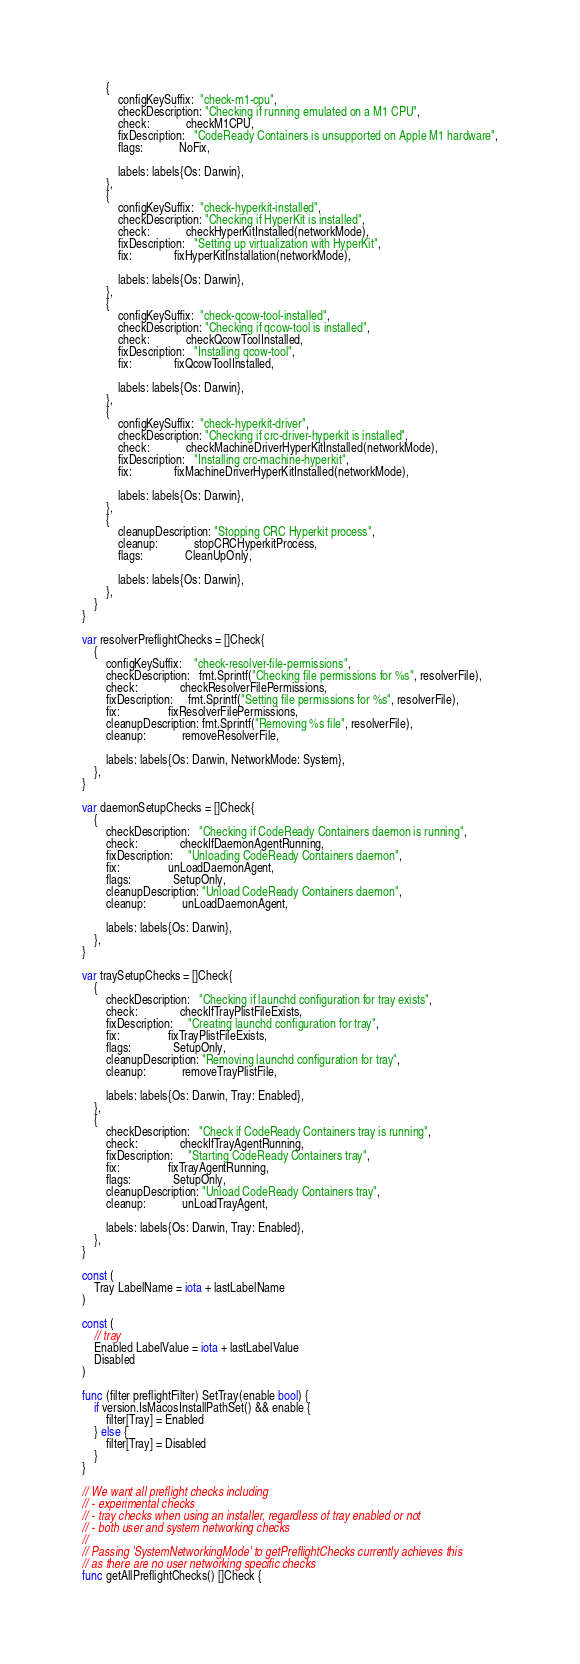<code> <loc_0><loc_0><loc_500><loc_500><_Go_>		{
			configKeySuffix:  "check-m1-cpu",
			checkDescription: "Checking if running emulated on a M1 CPU",
			check:            checkM1CPU,
			fixDescription:   "CodeReady Containers is unsupported on Apple M1 hardware",
			flags:            NoFix,

			labels: labels{Os: Darwin},
		},
		{
			configKeySuffix:  "check-hyperkit-installed",
			checkDescription: "Checking if HyperKit is installed",
			check:            checkHyperKitInstalled(networkMode),
			fixDescription:   "Setting up virtualization with HyperKit",
			fix:              fixHyperKitInstallation(networkMode),

			labels: labels{Os: Darwin},
		},
		{
			configKeySuffix:  "check-qcow-tool-installed",
			checkDescription: "Checking if qcow-tool is installed",
			check:            checkQcowToolInstalled,
			fixDescription:   "Installing qcow-tool",
			fix:              fixQcowToolInstalled,

			labels: labels{Os: Darwin},
		},
		{
			configKeySuffix:  "check-hyperkit-driver",
			checkDescription: "Checking if crc-driver-hyperkit is installed",
			check:            checkMachineDriverHyperKitInstalled(networkMode),
			fixDescription:   "Installing crc-machine-hyperkit",
			fix:              fixMachineDriverHyperKitInstalled(networkMode),

			labels: labels{Os: Darwin},
		},
		{
			cleanupDescription: "Stopping CRC Hyperkit process",
			cleanup:            stopCRCHyperkitProcess,
			flags:              CleanUpOnly,

			labels: labels{Os: Darwin},
		},
	}
}

var resolverPreflightChecks = []Check{
	{
		configKeySuffix:    "check-resolver-file-permissions",
		checkDescription:   fmt.Sprintf("Checking file permissions for %s", resolverFile),
		check:              checkResolverFilePermissions,
		fixDescription:     fmt.Sprintf("Setting file permissions for %s", resolverFile),
		fix:                fixResolverFilePermissions,
		cleanupDescription: fmt.Sprintf("Removing %s file", resolverFile),
		cleanup:            removeResolverFile,

		labels: labels{Os: Darwin, NetworkMode: System},
	},
}

var daemonSetupChecks = []Check{
	{
		checkDescription:   "Checking if CodeReady Containers daemon is running",
		check:              checkIfDaemonAgentRunning,
		fixDescription:     "Unloading CodeReady Containers daemon",
		fix:                unLoadDaemonAgent,
		flags:              SetupOnly,
		cleanupDescription: "Unload CodeReady Containers daemon",
		cleanup:            unLoadDaemonAgent,

		labels: labels{Os: Darwin},
	},
}

var traySetupChecks = []Check{
	{
		checkDescription:   "Checking if launchd configuration for tray exists",
		check:              checkIfTrayPlistFileExists,
		fixDescription:     "Creating launchd configuration for tray",
		fix:                fixTrayPlistFileExists,
		flags:              SetupOnly,
		cleanupDescription: "Removing launchd configuration for tray",
		cleanup:            removeTrayPlistFile,

		labels: labels{Os: Darwin, Tray: Enabled},
	},
	{
		checkDescription:   "Check if CodeReady Containers tray is running",
		check:              checkIfTrayAgentRunning,
		fixDescription:     "Starting CodeReady Containers tray",
		fix:                fixTrayAgentRunning,
		flags:              SetupOnly,
		cleanupDescription: "Unload CodeReady Containers tray",
		cleanup:            unLoadTrayAgent,

		labels: labels{Os: Darwin, Tray: Enabled},
	},
}

const (
	Tray LabelName = iota + lastLabelName
)

const (
	// tray
	Enabled LabelValue = iota + lastLabelValue
	Disabled
)

func (filter preflightFilter) SetTray(enable bool) {
	if version.IsMacosInstallPathSet() && enable {
		filter[Tray] = Enabled
	} else {
		filter[Tray] = Disabled
	}
}

// We want all preflight checks including
// - experimental checks
// - tray checks when using an installer, regardless of tray enabled or not
// - both user and system networking checks
//
// Passing 'SystemNetworkingMode' to getPreflightChecks currently achieves this
// as there are no user networking specific checks
func getAllPreflightChecks() []Check {</code> 